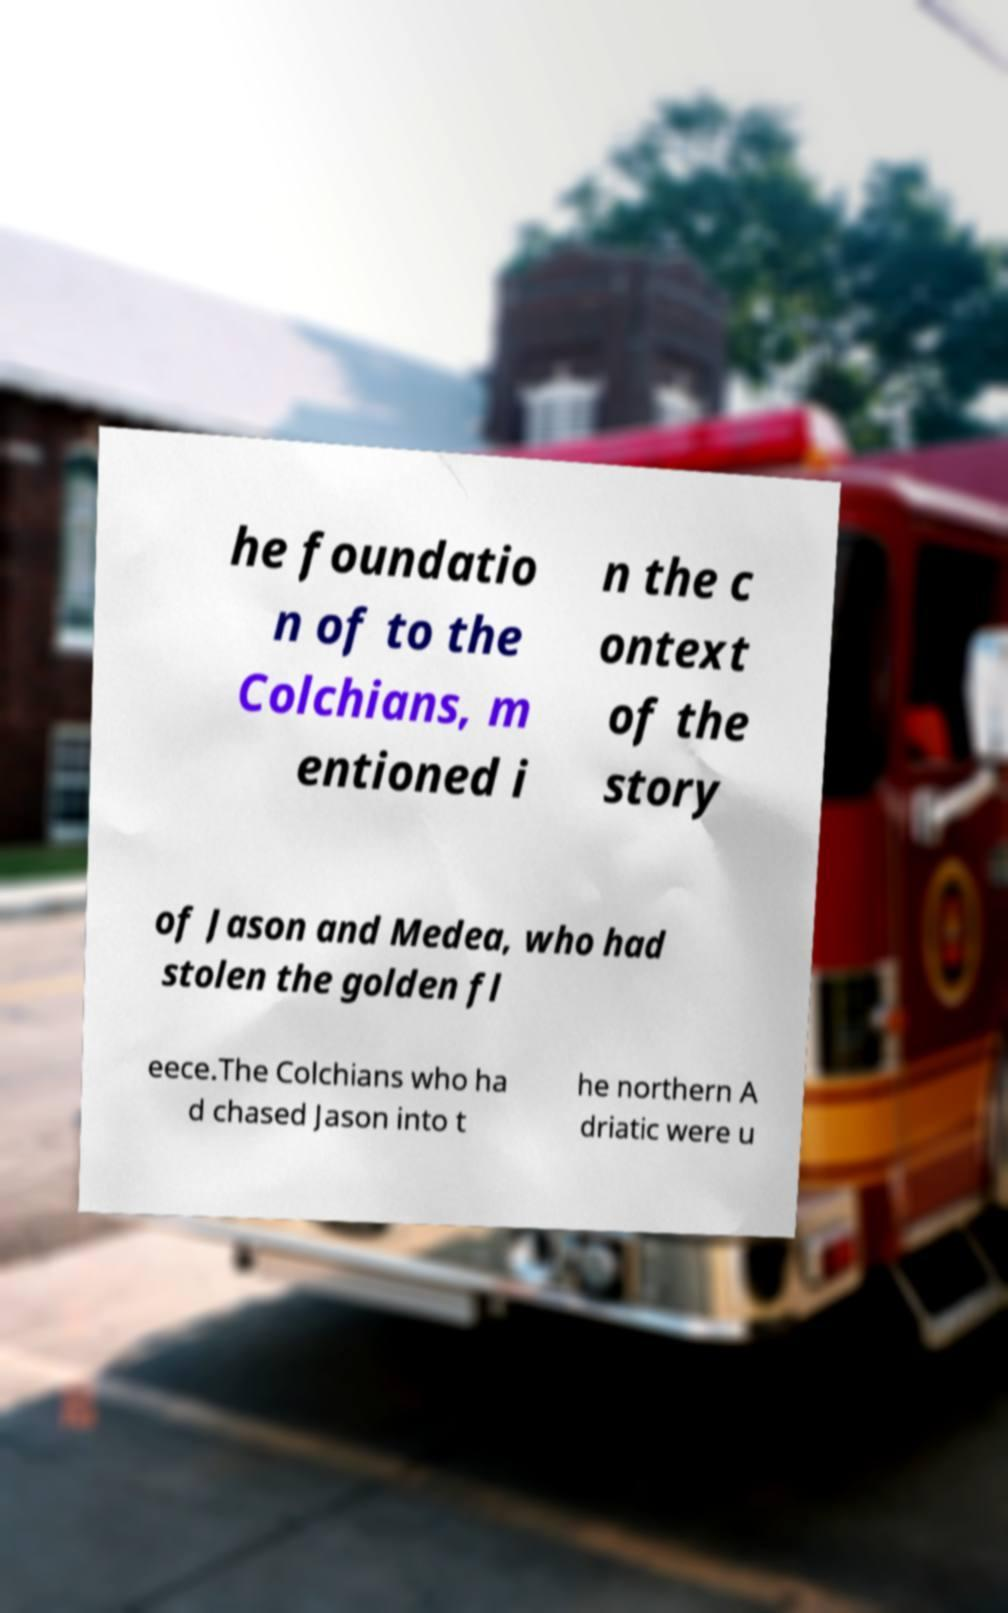Can you accurately transcribe the text from the provided image for me? he foundatio n of to the Colchians, m entioned i n the c ontext of the story of Jason and Medea, who had stolen the golden fl eece.The Colchians who ha d chased Jason into t he northern A driatic were u 